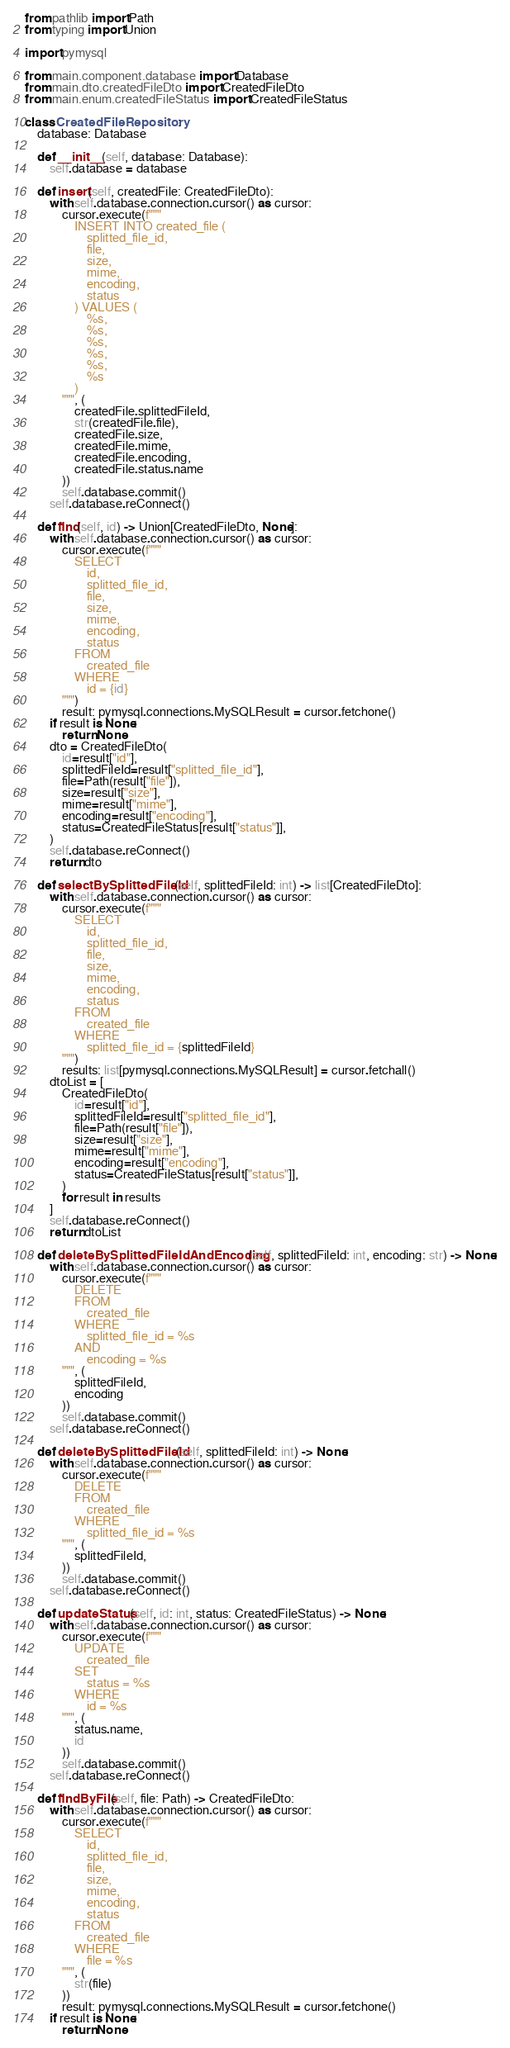Convert code to text. <code><loc_0><loc_0><loc_500><loc_500><_Python_>from pathlib import Path
from typing import Union

import pymysql

from main.component.database import Database
from main.dto.createdFileDto import CreatedFileDto
from main.enum.createdFileStatus import CreatedFileStatus

class CreatedFileRepository:
    database: Database

    def __init__(self, database: Database):
        self.database = database

    def insert(self, createdFile: CreatedFileDto):
        with self.database.connection.cursor() as cursor:
            cursor.execute(f"""
                INSERT INTO created_file (
                    splitted_file_id,
                    file,
                    size,
                    mime,
                    encoding,
                    status
                ) VALUES (
                    %s,
                    %s,
                    %s,
                    %s,
                    %s,
                    %s
                )
            """, (
                createdFile.splittedFileId,
                str(createdFile.file),
                createdFile.size,
                createdFile.mime,
                createdFile.encoding,
                createdFile.status.name
            ))
            self.database.commit()
        self.database.reConnect()

    def find(self, id) -> Union[CreatedFileDto, None]:
        with self.database.connection.cursor() as cursor:
            cursor.execute(f"""
                SELECT
                    id,
                    splitted_file_id,
                    file,
                    size,
                    mime,
                    encoding,
                    status
                FROM
                    created_file
                WHERE
                    id = {id}
            """)
            result: pymysql.connections.MySQLResult = cursor.fetchone()
        if result is None:
            return None
        dto = CreatedFileDto(
            id=result["id"],
            splittedFileId=result["splitted_file_id"],
            file=Path(result["file"]),
            size=result["size"],
            mime=result["mime"],
            encoding=result["encoding"],
            status=CreatedFileStatus[result["status"]],
        )
        self.database.reConnect()
        return dto

    def selectBySplittedFileId(self, splittedFileId: int) -> list[CreatedFileDto]:
        with self.database.connection.cursor() as cursor:
            cursor.execute(f"""
                SELECT
                    id,
                    splitted_file_id,
                    file,
                    size,
                    mime,
                    encoding,
                    status
                FROM
                    created_file
                WHERE
                    splitted_file_id = {splittedFileId}
            """)
            results: list[pymysql.connections.MySQLResult] = cursor.fetchall()
        dtoList = [
            CreatedFileDto(
                id=result["id"],
                splittedFileId=result["splitted_file_id"],
                file=Path(result["file"]),
                size=result["size"],
                mime=result["mime"],
                encoding=result["encoding"],
                status=CreatedFileStatus[result["status"]],
            )
            for result in results
        ]
        self.database.reConnect()
        return dtoList

    def deleteBySplittedFileIdAndEncoding(self, splittedFileId: int, encoding: str) -> None:
        with self.database.connection.cursor() as cursor:
            cursor.execute(f"""
                DELETE
                FROM
                    created_file
                WHERE
                    splitted_file_id = %s
                AND
                    encoding = %s
            """, (
                splittedFileId,
                encoding
            ))
            self.database.commit()
        self.database.reConnect()

    def deleteBySplittedFileId(self, splittedFileId: int) -> None:
        with self.database.connection.cursor() as cursor:
            cursor.execute(f"""
                DELETE
                FROM
                    created_file
                WHERE
                    splitted_file_id = %s
            """, (
                splittedFileId,
            ))
            self.database.commit()
        self.database.reConnect()

    def updateStatus(self, id: int, status: CreatedFileStatus) -> None:
        with self.database.connection.cursor() as cursor:
            cursor.execute(f"""
                UPDATE
                    created_file
                SET
                    status = %s
                WHERE
                    id = %s
            """, (
                status.name,
                id
            ))
            self.database.commit()
        self.database.reConnect()

    def findByFile(self, file: Path) -> CreatedFileDto:
        with self.database.connection.cursor() as cursor:
            cursor.execute(f"""
                SELECT
                    id,
                    splitted_file_id,
                    file,
                    size,
                    mime,
                    encoding,
                    status
                FROM
                    created_file
                WHERE
                    file = %s
            """, (
                str(file)
            ))
            result: pymysql.connections.MySQLResult = cursor.fetchone()
        if result is None:
            return None</code> 